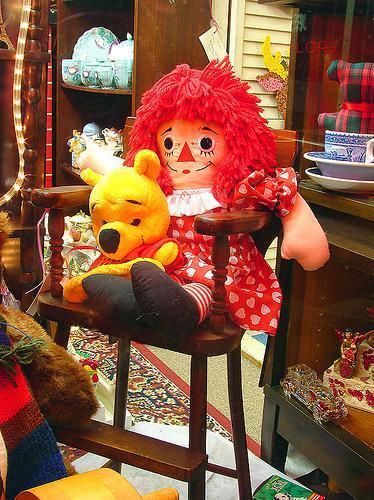How many teddy bears can be seen?
Give a very brief answer. 3. 